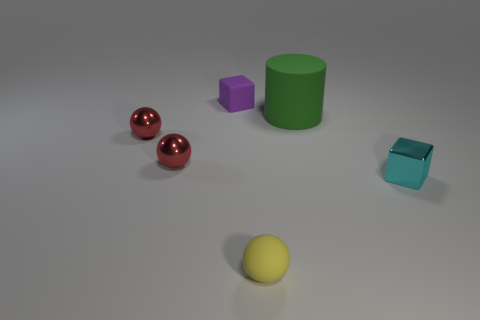Is the material of the tiny cube in front of the rubber cylinder the same as the yellow ball?
Keep it short and to the point. No. The small rubber thing in front of the rubber cylinder has what shape?
Make the answer very short. Sphere. What number of red metallic spheres are the same size as the yellow matte ball?
Provide a succinct answer. 2. What is the size of the green cylinder?
Offer a very short reply. Large. There is a green matte thing; what number of small purple things are right of it?
Provide a short and direct response. 0. What shape is the green object that is made of the same material as the purple block?
Give a very brief answer. Cylinder. Are there fewer small spheres that are in front of the yellow matte object than small rubber things that are behind the big green thing?
Your response must be concise. Yes. Are there more green rubber cylinders than small red metal balls?
Offer a very short reply. No. What is the cyan object made of?
Keep it short and to the point. Metal. The small block that is on the right side of the green matte cylinder is what color?
Keep it short and to the point. Cyan. 